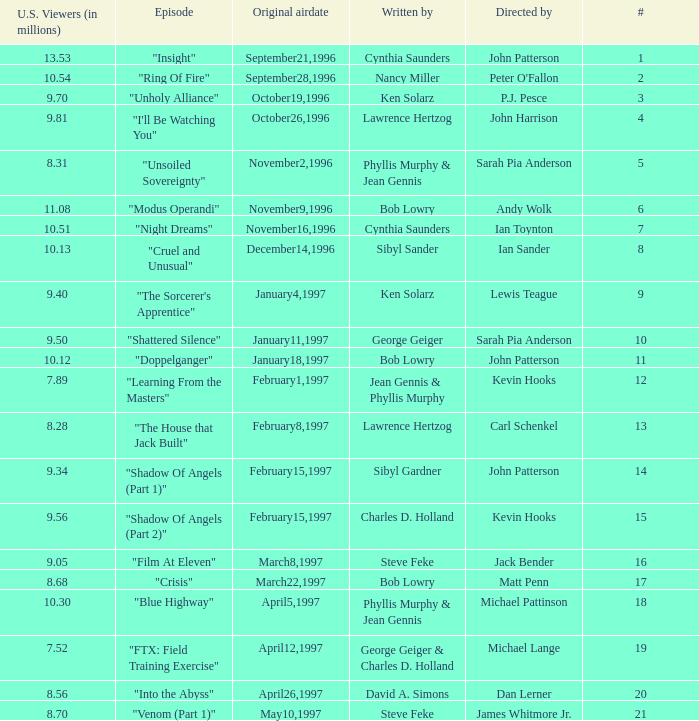Who wrote the episode with 7.52 million US viewers? George Geiger & Charles D. Holland. 